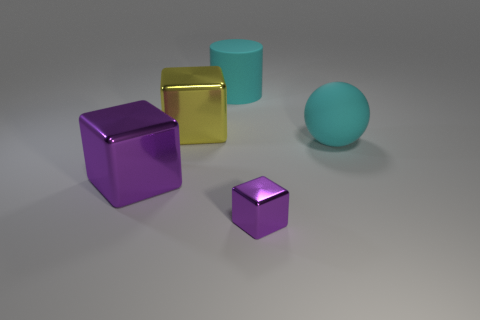Add 5 big cylinders. How many objects exist? 10 Subtract all cylinders. How many objects are left? 4 Add 4 gray metal cubes. How many gray metal cubes exist? 4 Subtract 0 red cylinders. How many objects are left? 5 Subtract all small shiny cubes. Subtract all cyan things. How many objects are left? 2 Add 1 small purple metal cubes. How many small purple metal cubes are left? 2 